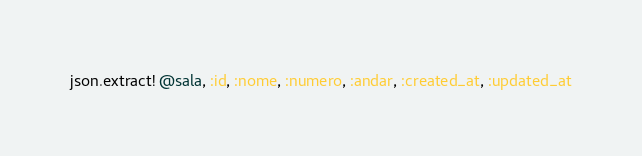<code> <loc_0><loc_0><loc_500><loc_500><_Ruby_>json.extract! @sala, :id, :nome, :numero, :andar, :created_at, :updated_at
</code> 